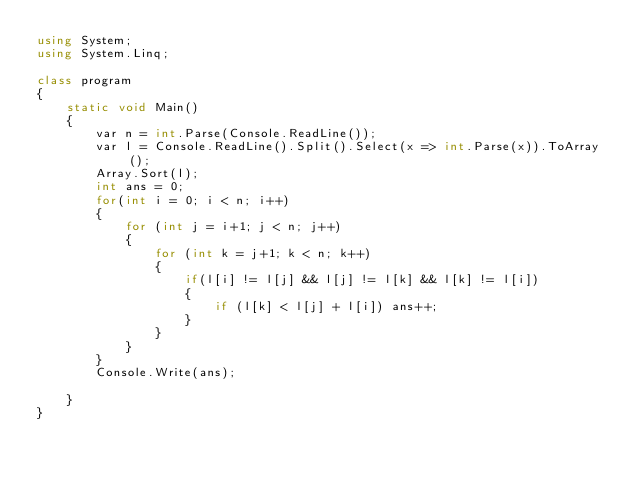Convert code to text. <code><loc_0><loc_0><loc_500><loc_500><_C#_>using System;
using System.Linq;

class program
{
    static void Main()
    {
        var n = int.Parse(Console.ReadLine());
        var l = Console.ReadLine().Split().Select(x => int.Parse(x)).ToArray();
        Array.Sort(l);
        int ans = 0;
        for(int i = 0; i < n; i++)
        {
            for (int j = i+1; j < n; j++)
            {
                for (int k = j+1; k < n; k++)
                {
                    if(l[i] != l[j] && l[j] != l[k] && l[k] != l[i])
                    {
                        if (l[k] < l[j] + l[i]) ans++;
                    }
                }
            }
        }
        Console.Write(ans);
                
    }
}</code> 